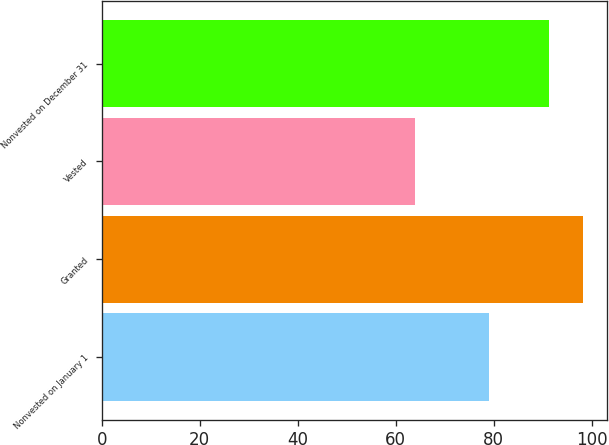Convert chart. <chart><loc_0><loc_0><loc_500><loc_500><bar_chart><fcel>Nonvested on January 1<fcel>Granted<fcel>Vested<fcel>Nonvested on December 31<nl><fcel>79.02<fcel>98.1<fcel>64.01<fcel>91.19<nl></chart> 